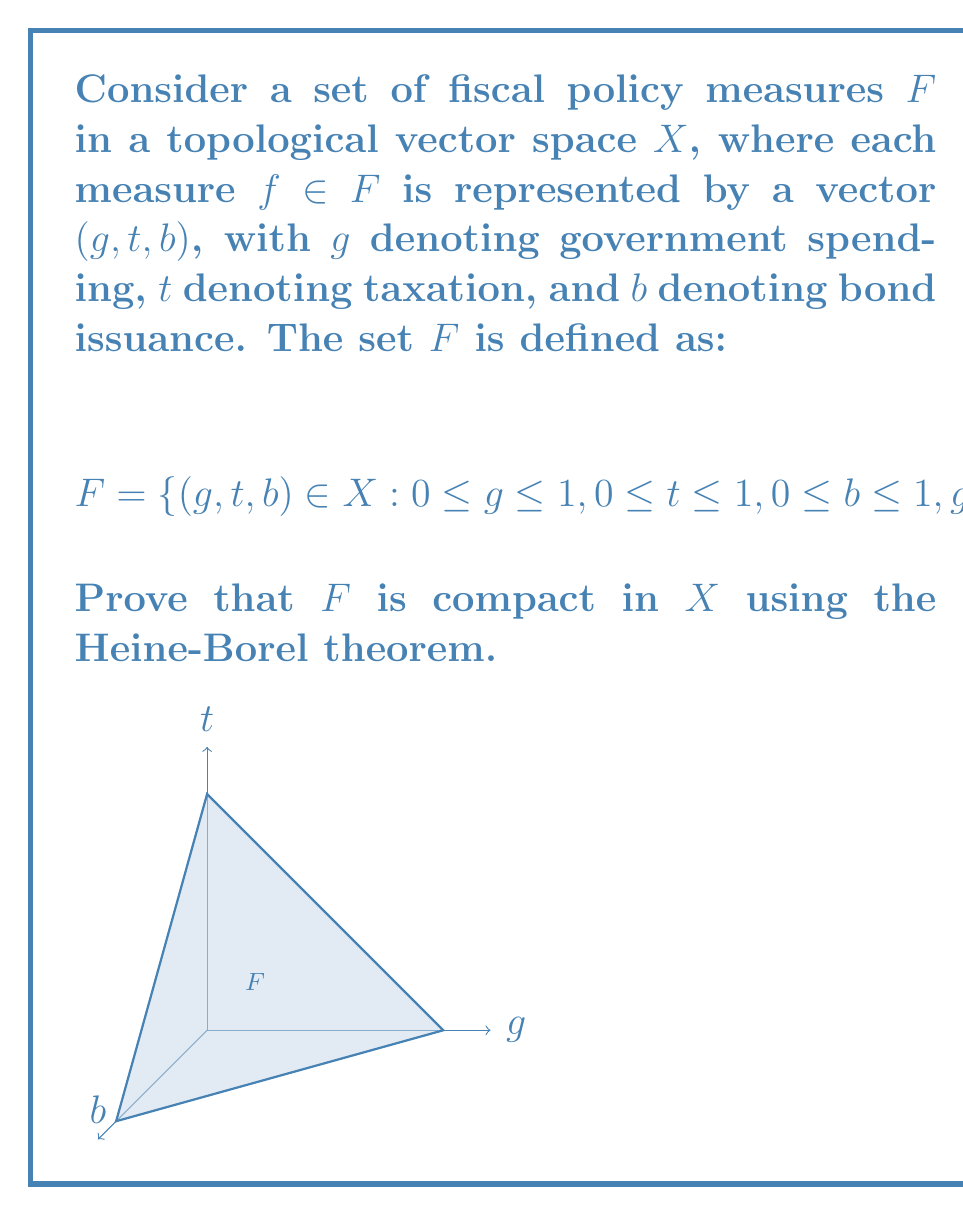Can you solve this math problem? To prove that $F$ is compact in $X$ using the Heine-Borel theorem, we need to show that $F$ is closed and bounded.

Step 1: Show that $F$ is closed.
$F$ is defined by a set of continuous inequalities and one equality:
$$0 \leq g \leq 1, 0 \leq t \leq 1, 0 \leq b \leq 1, g + t + b = 1$$
These conditions form a closed set in $X$ as they include their boundary points.

Step 2: Show that $F$ is bounded.
Each component of the vectors in $F$ is bounded:
$$0 \leq g \leq 1, 0 \leq t \leq 1, 0 \leq b \leq 1$$
This implies that $F$ is contained within a unit cube in $X$, which is a bounded set.

Step 3: Apply the Heine-Borel theorem.
The Heine-Borel theorem states that in a finite-dimensional normed vector space, a set is compact if and only if it is closed and bounded.

Since we have shown that $F$ is both closed and bounded in $X$, and $X$ is a topological vector space (which includes finite-dimensional normed vector spaces), we can conclude that $F$ is compact.

Step 4: Interpret the result.
In the context of fiscal policy, this result implies that the set of all possible combinations of government spending, taxation, and bond issuance that satisfy the given constraints forms a compact set. This means that any sequence of fiscal policy measures within this set will have a convergent subsequence, which is crucial for analyzing the long-term effects and stability of fiscal policies.
Answer: $F$ is compact in $X$ as it is closed and bounded in a finite-dimensional normed vector space. 